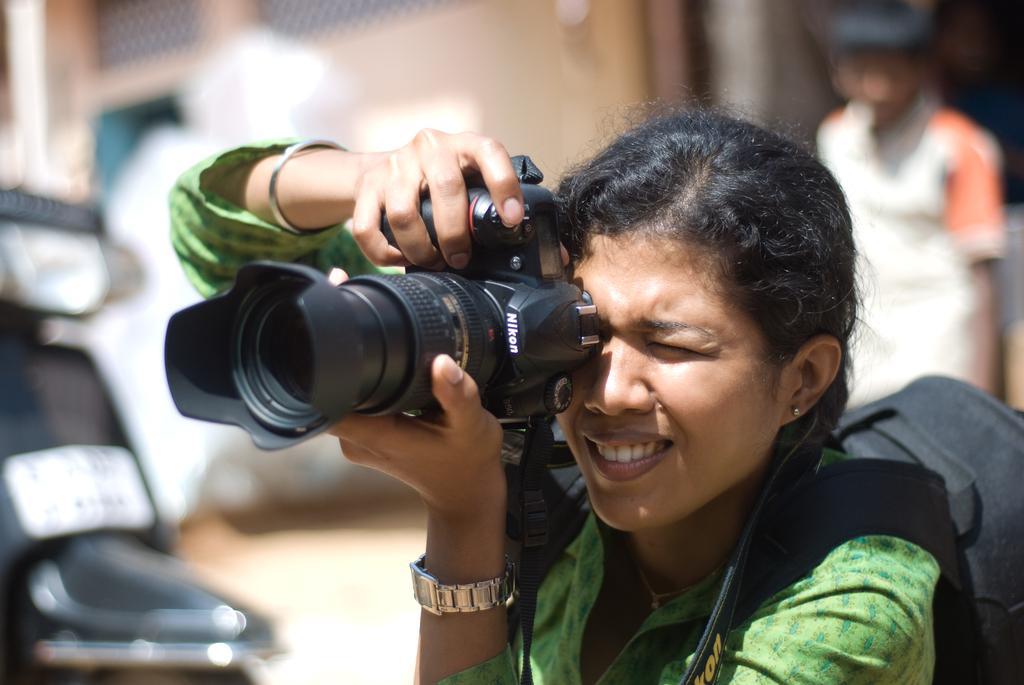Describe this image in one or two sentences. in this image i can see a woman holding a camera. she is wearing a black color bag. behind her there is a person standing and at the left there is a scooter 